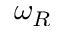<formula> <loc_0><loc_0><loc_500><loc_500>\omega _ { R }</formula> 